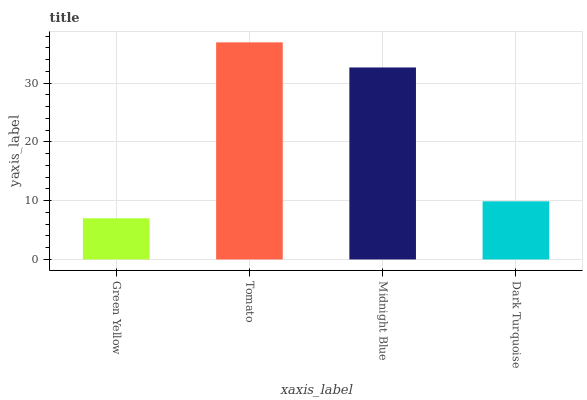Is Green Yellow the minimum?
Answer yes or no. Yes. Is Tomato the maximum?
Answer yes or no. Yes. Is Midnight Blue the minimum?
Answer yes or no. No. Is Midnight Blue the maximum?
Answer yes or no. No. Is Tomato greater than Midnight Blue?
Answer yes or no. Yes. Is Midnight Blue less than Tomato?
Answer yes or no. Yes. Is Midnight Blue greater than Tomato?
Answer yes or no. No. Is Tomato less than Midnight Blue?
Answer yes or no. No. Is Midnight Blue the high median?
Answer yes or no. Yes. Is Dark Turquoise the low median?
Answer yes or no. Yes. Is Dark Turquoise the high median?
Answer yes or no. No. Is Tomato the low median?
Answer yes or no. No. 